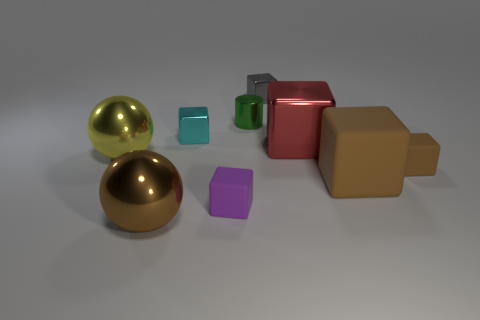Subtract 1 blocks. How many blocks are left? 5 Subtract all cyan blocks. How many blocks are left? 5 Subtract all red metallic cubes. How many cubes are left? 5 Subtract all gray cubes. Subtract all red cylinders. How many cubes are left? 5 Add 1 rubber cubes. How many objects exist? 10 Subtract all cylinders. How many objects are left? 8 Subtract 0 green cubes. How many objects are left? 9 Subtract all large yellow spheres. Subtract all yellow shiny spheres. How many objects are left? 7 Add 2 purple rubber objects. How many purple rubber objects are left? 3 Add 6 tiny metallic things. How many tiny metallic things exist? 9 